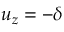<formula> <loc_0><loc_0><loc_500><loc_500>u _ { z } = - \delta</formula> 